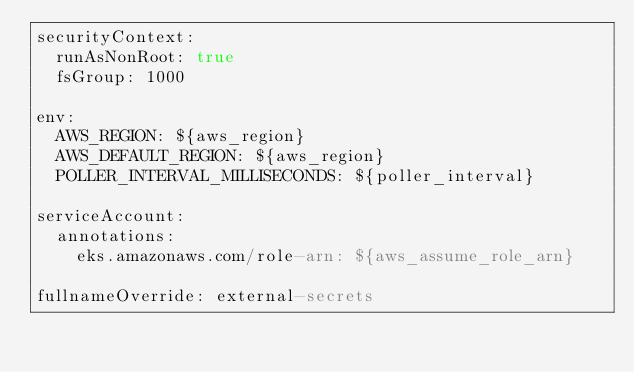<code> <loc_0><loc_0><loc_500><loc_500><_YAML_>securityContext:
  runAsNonRoot: true
  fsGroup: 1000

env:
  AWS_REGION: ${aws_region}
  AWS_DEFAULT_REGION: ${aws_region}
  POLLER_INTERVAL_MILLISECONDS: ${poller_interval}

serviceAccount:
  annotations: 
    eks.amazonaws.com/role-arn: ${aws_assume_role_arn}
  
fullnameOverride: external-secrets
</code> 